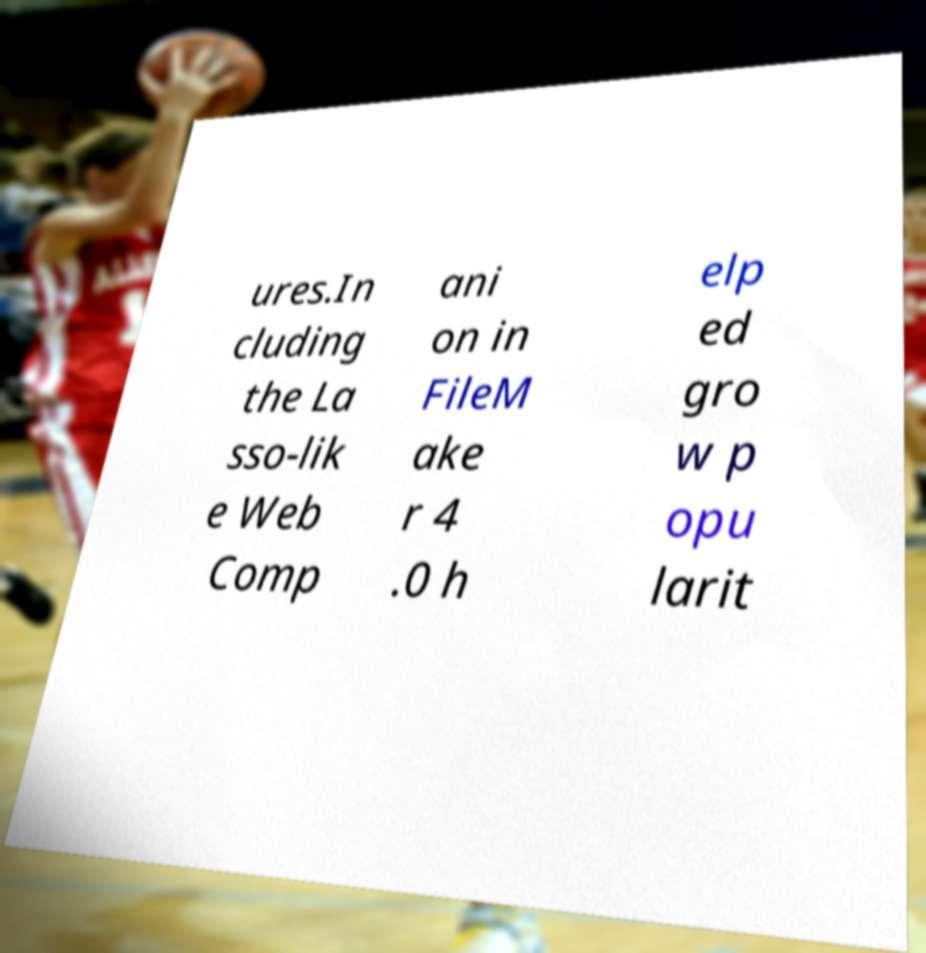Could you extract and type out the text from this image? ures.In cluding the La sso-lik e Web Comp ani on in FileM ake r 4 .0 h elp ed gro w p opu larit 